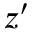<formula> <loc_0><loc_0><loc_500><loc_500>z ^ { \prime }</formula> 